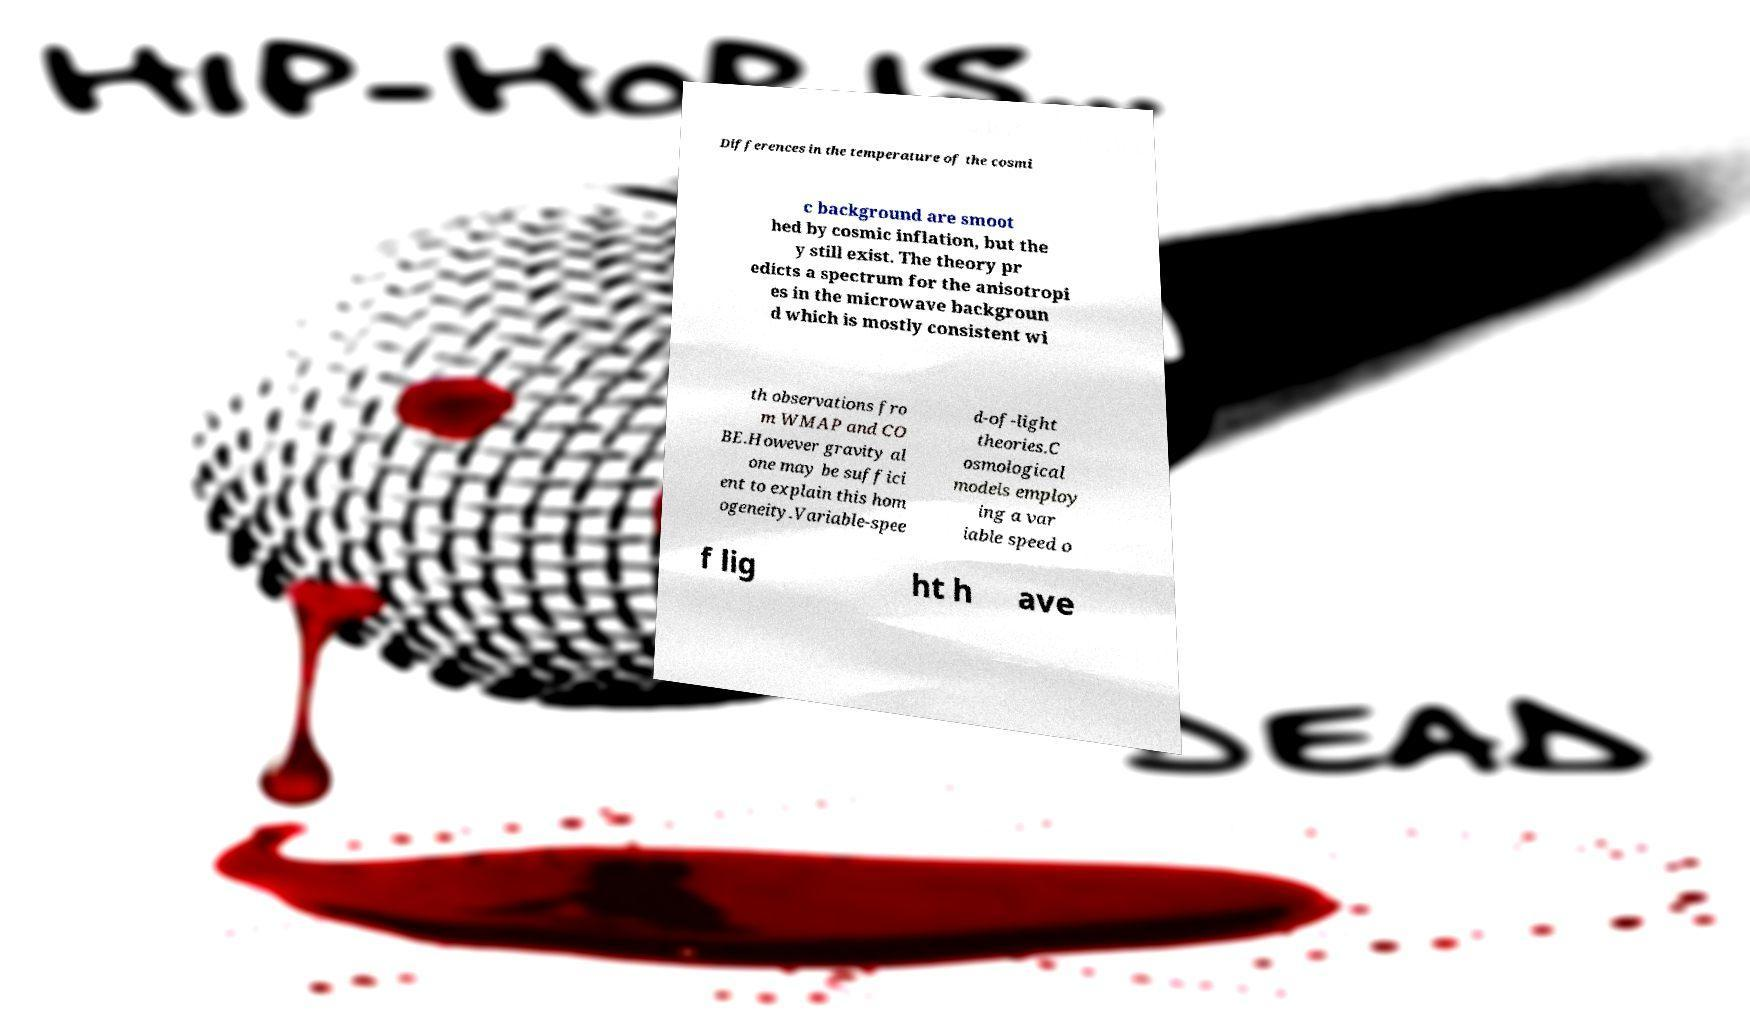Could you extract and type out the text from this image? Differences in the temperature of the cosmi c background are smoot hed by cosmic inflation, but the y still exist. The theory pr edicts a spectrum for the anisotropi es in the microwave backgroun d which is mostly consistent wi th observations fro m WMAP and CO BE.However gravity al one may be suffici ent to explain this hom ogeneity.Variable-spee d-of-light theories.C osmological models employ ing a var iable speed o f lig ht h ave 